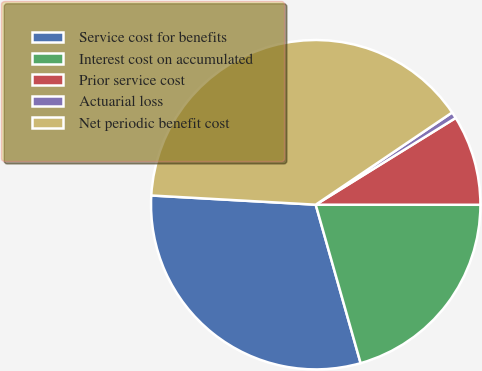<chart> <loc_0><loc_0><loc_500><loc_500><pie_chart><fcel>Service cost for benefits<fcel>Interest cost on accumulated<fcel>Prior service cost<fcel>Actuarial loss<fcel>Net periodic benefit cost<nl><fcel>30.29%<fcel>20.6%<fcel>8.84%<fcel>0.63%<fcel>39.65%<nl></chart> 